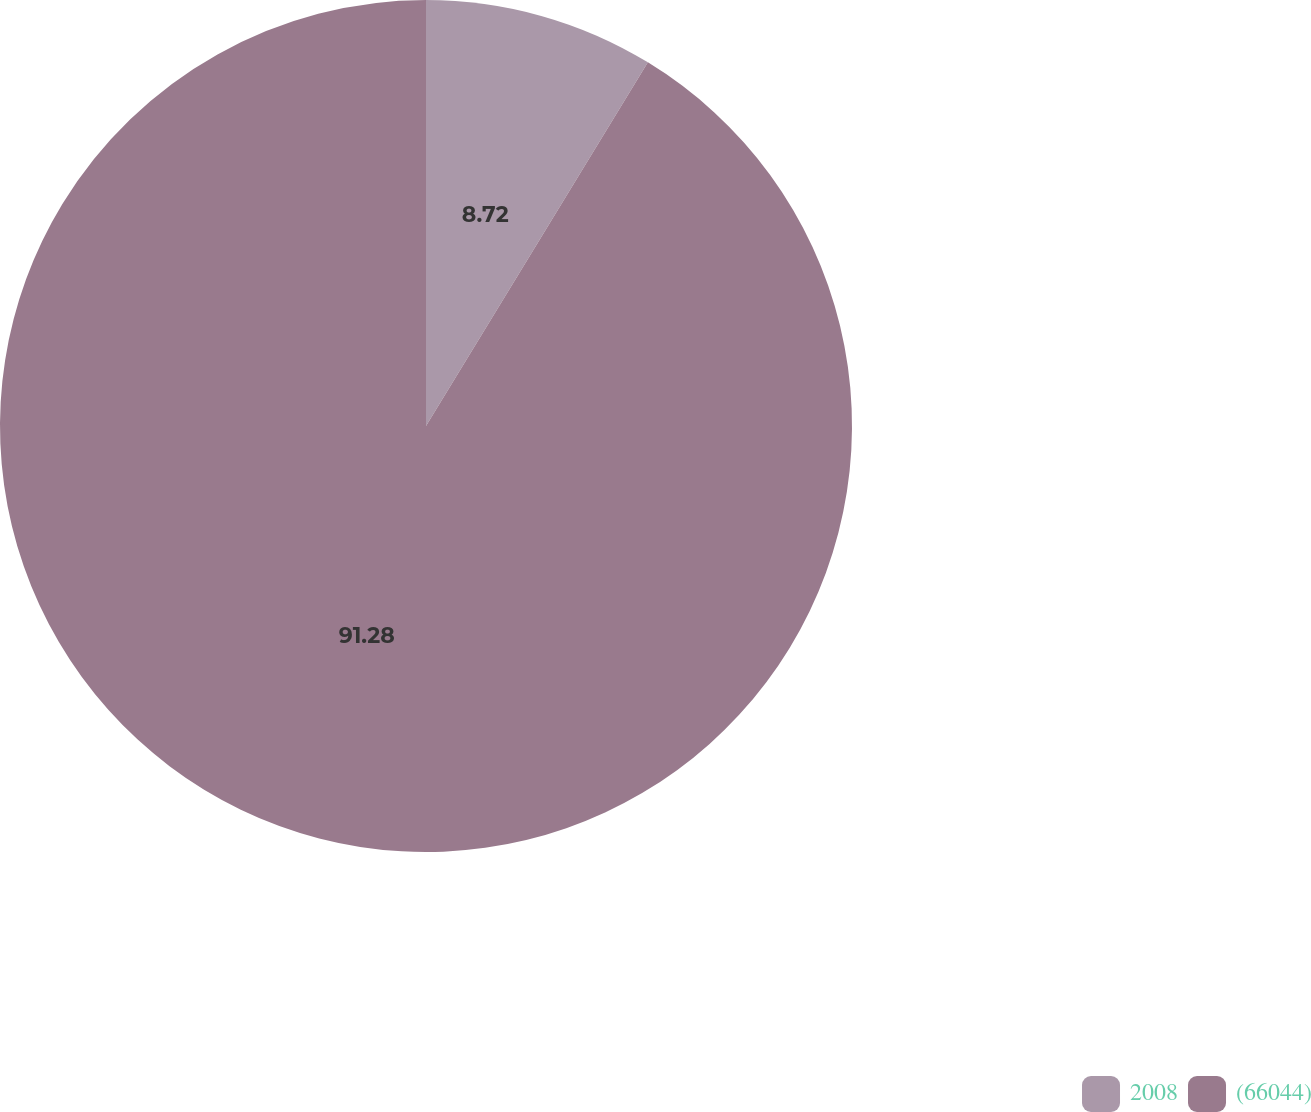<chart> <loc_0><loc_0><loc_500><loc_500><pie_chart><fcel>2008<fcel>(66044)<nl><fcel>8.72%<fcel>91.28%<nl></chart> 